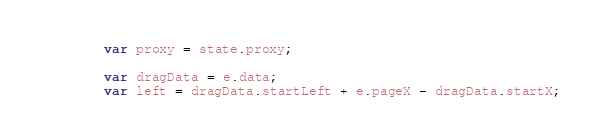<code> <loc_0><loc_0><loc_500><loc_500><_JavaScript_>		var proxy = state.proxy;
		
		var dragData = e.data;
		var left = dragData.startLeft + e.pageX - dragData.startX;</code> 